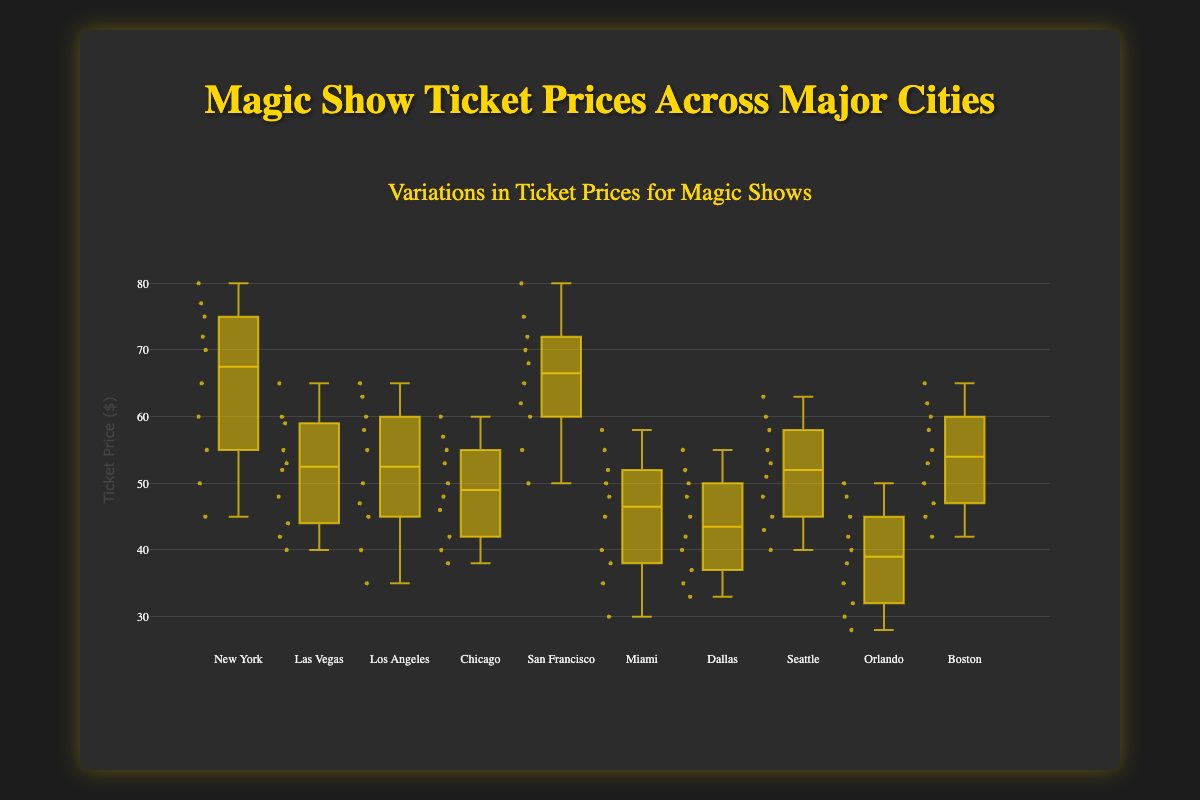What is the range of ticket prices in New York? To find the range, we need to subtract the minimum ticket price from the maximum ticket price. In New York, the minimum ticket price is $45, and the maximum ticket price is $80. Therefore, the range is 80 - 45 = $35.
Answer: $35 What city has the highest median ticket price? The median ticket price is the middle value of the dataset. From the box plots, we can see that San Francisco and New York have higher median ticket prices than other cities. To identify the highest, we compare these medians: both are $67.5. Therefore, San Francisco has the highest median ticket price.
Answer: San Francisco Which city has the lowest minimum ticket price? To find the city with the lowest minimum ticket price, we look at the bottom whisker of each box plot representing the minimum value. Orlando has the lowest minimum ticket price of $28.
Answer: Orlando How does the interquartile range (IQR) of Miami compare to that of Seattle? The IQR is calculated by subtracting the first quartile (Q1) from the third quartile (Q3). For Miami, Q3 is $52 and Q1 is $38, giving an IQR of 52 - 38 = $14. For Seattle, Q3 is $57 and Q1 is $45, giving an IQR of 57 - 45 = $12. Therefore, Miami's IQR is larger than Seattle's by $2.
Answer: Miami's IQR is larger by $2 What is the median ticket price in Las Vegas? The median is the middle value of the dataset, represented by the line inside the box in a box plot. For Las Vegas, the median ticket price is $52.
Answer: $52 Which city has the most dispersed ticket prices? Dispersion is often measured by the range, which is the difference between the maximum and minimum values. From the box plots, San Francisco has the maximum ticket price of $80 and a minimum of $50, giving a range of 80 - 50 = $30, which is the broadest range among the cities.
Answer: San Francisco What is the upper quartile (Q3) value for Chicago? The upper quartile (Q3) is the value at the 75th percentile and can be found at the top of the box in the box plot. For Chicago, Q3 is $57.
Answer: $57 Compare the median values of Boston and Los Angeles. Which city has a higher median? The median is the middle value represented by the line within the box. For Boston, the median ticket price is $57, and for Los Angeles, it is $52. Therefore, Boston has a higher median ticket price.
Answer: Boston How many outliers does San Francisco have? Outliers are data points that lie outside the whiskers of the box plot. For San Francisco, the points outside the whiskers are none, which means there are no outliers.
Answer: None 